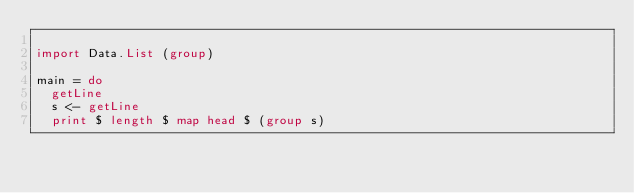Convert code to text. <code><loc_0><loc_0><loc_500><loc_500><_Haskell_>
import Data.List (group)

main = do
  getLine
  s <- getLine
  print $ length $ map head $ (group s)</code> 